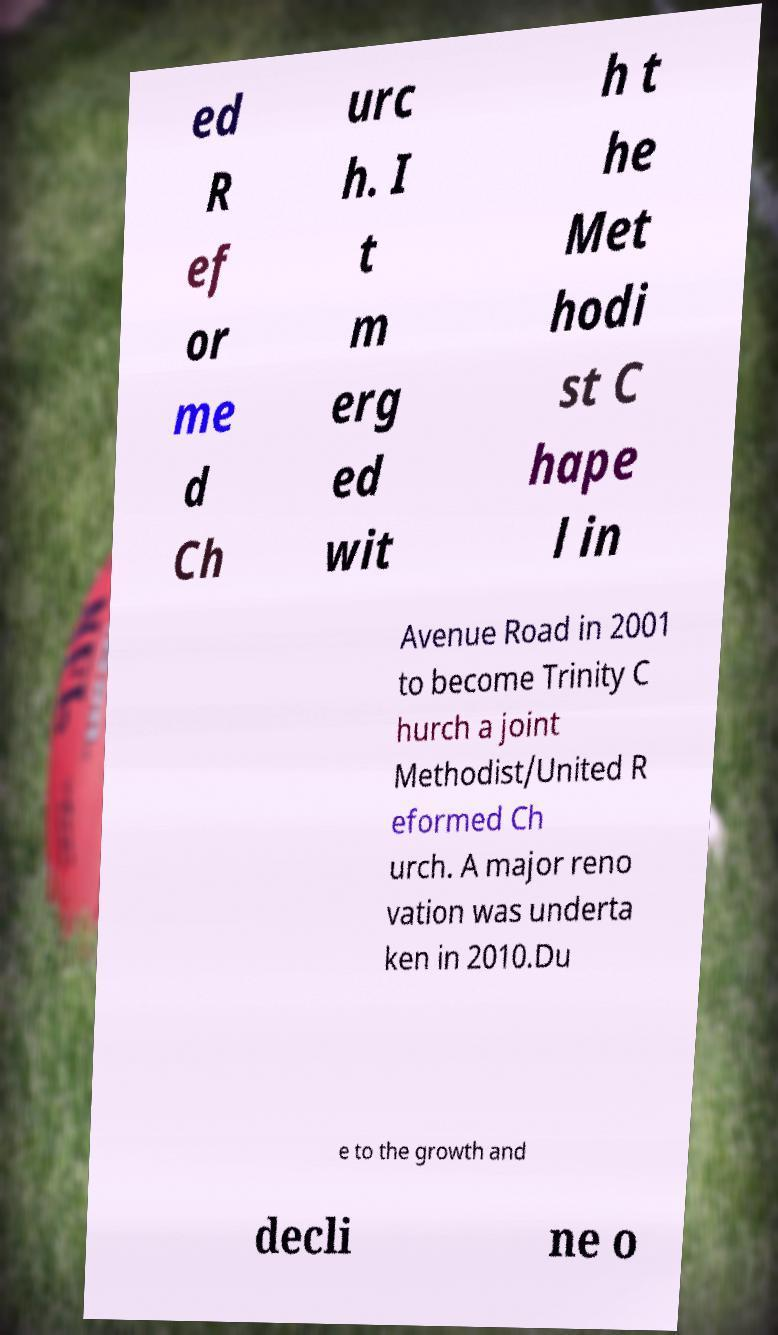What messages or text are displayed in this image? I need them in a readable, typed format. ed R ef or me d Ch urc h. I t m erg ed wit h t he Met hodi st C hape l in Avenue Road in 2001 to become Trinity C hurch a joint Methodist/United R eformed Ch urch. A major reno vation was underta ken in 2010.Du e to the growth and decli ne o 